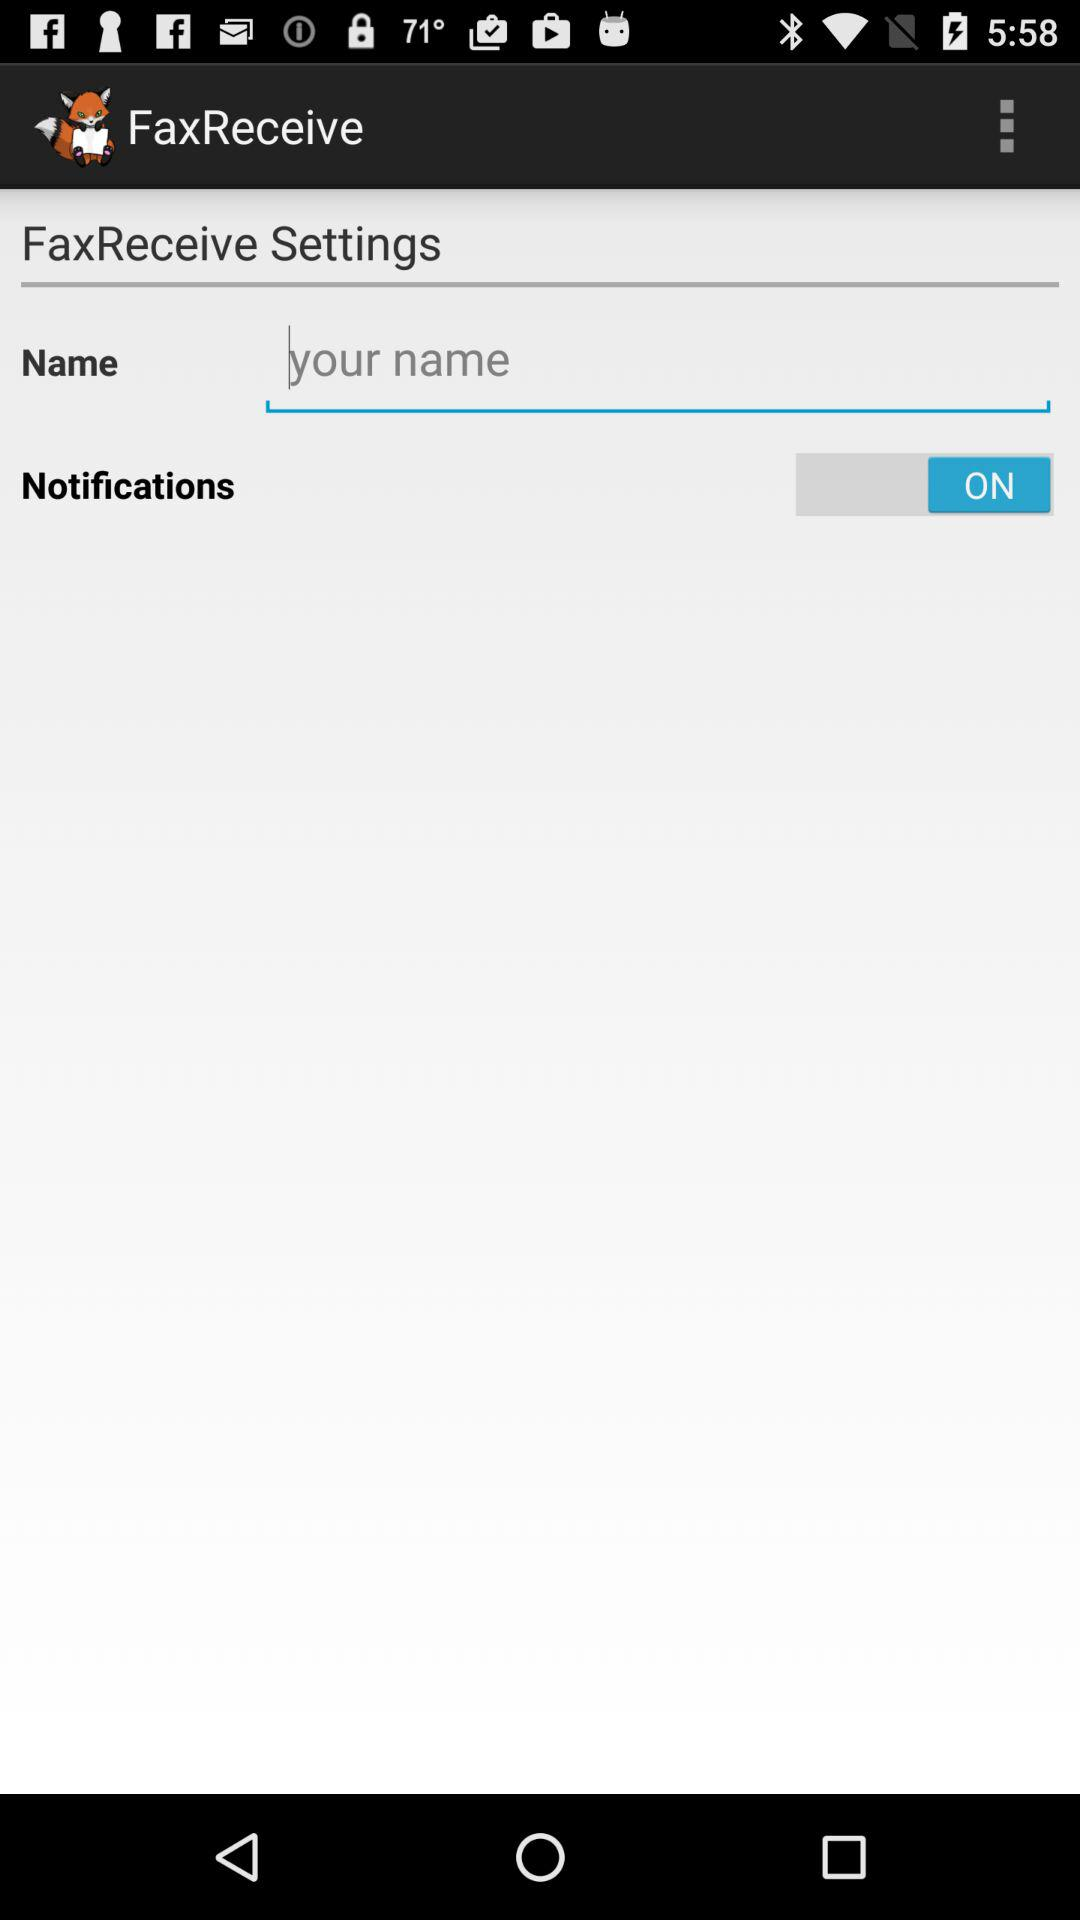What is the application name? The application name is "FaxReceive". 